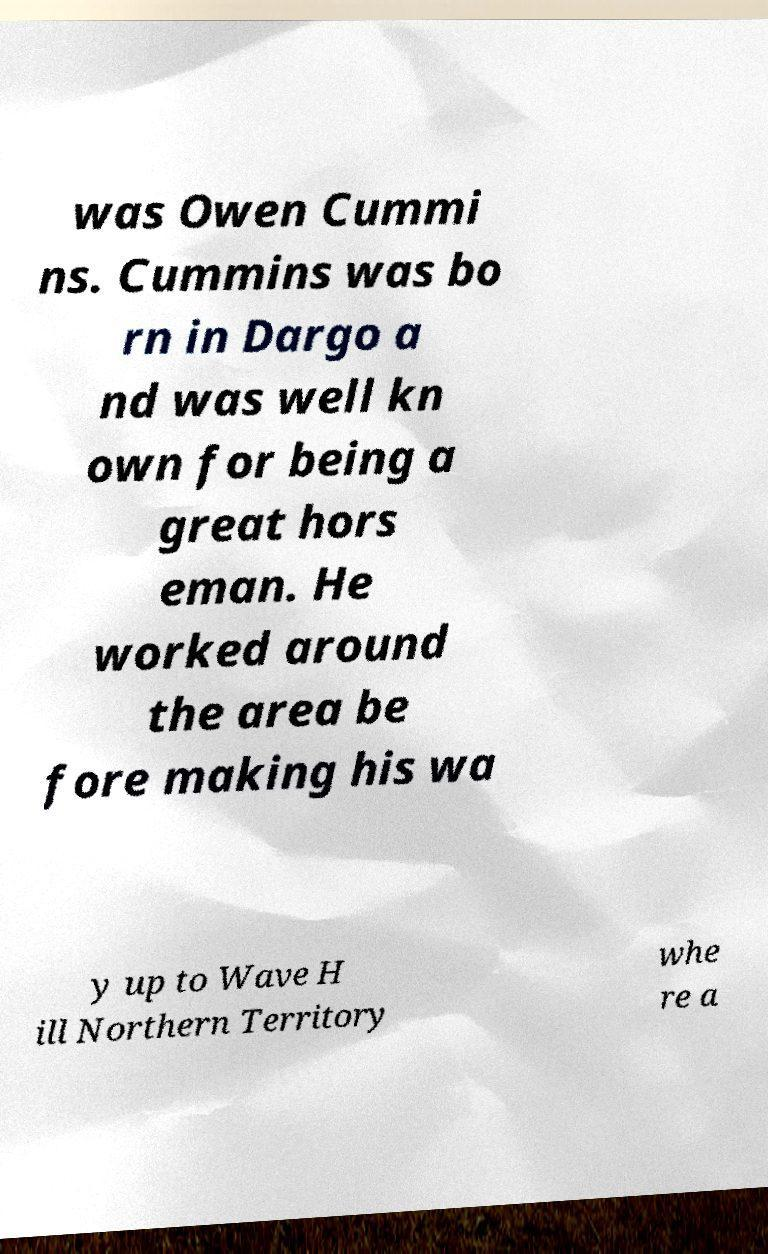Can you read and provide the text displayed in the image?This photo seems to have some interesting text. Can you extract and type it out for me? was Owen Cummi ns. Cummins was bo rn in Dargo a nd was well kn own for being a great hors eman. He worked around the area be fore making his wa y up to Wave H ill Northern Territory whe re a 